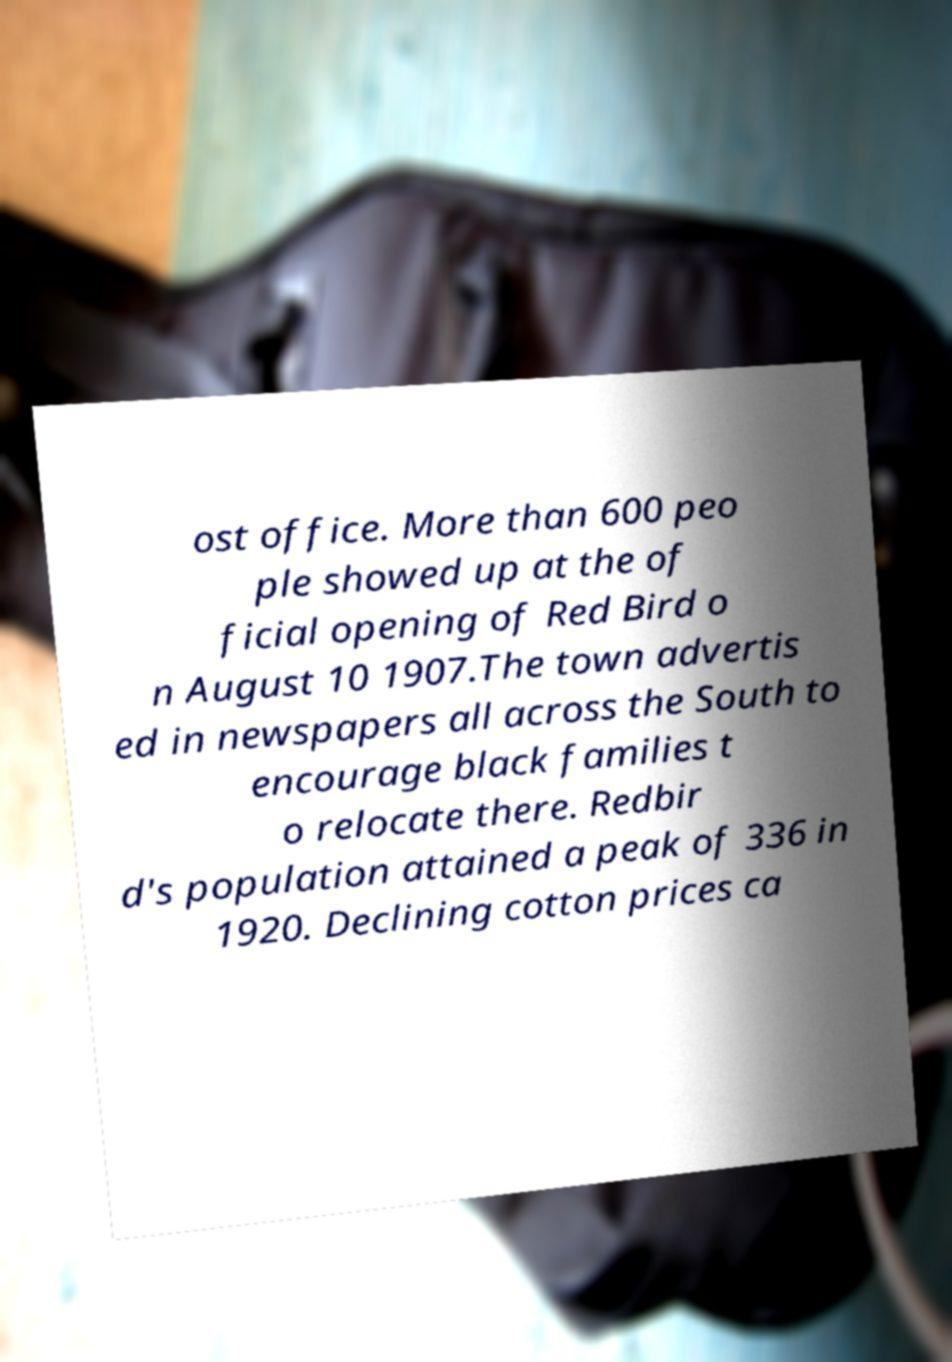Can you accurately transcribe the text from the provided image for me? ost office. More than 600 peo ple showed up at the of ficial opening of Red Bird o n August 10 1907.The town advertis ed in newspapers all across the South to encourage black families t o relocate there. Redbir d's population attained a peak of 336 in 1920. Declining cotton prices ca 